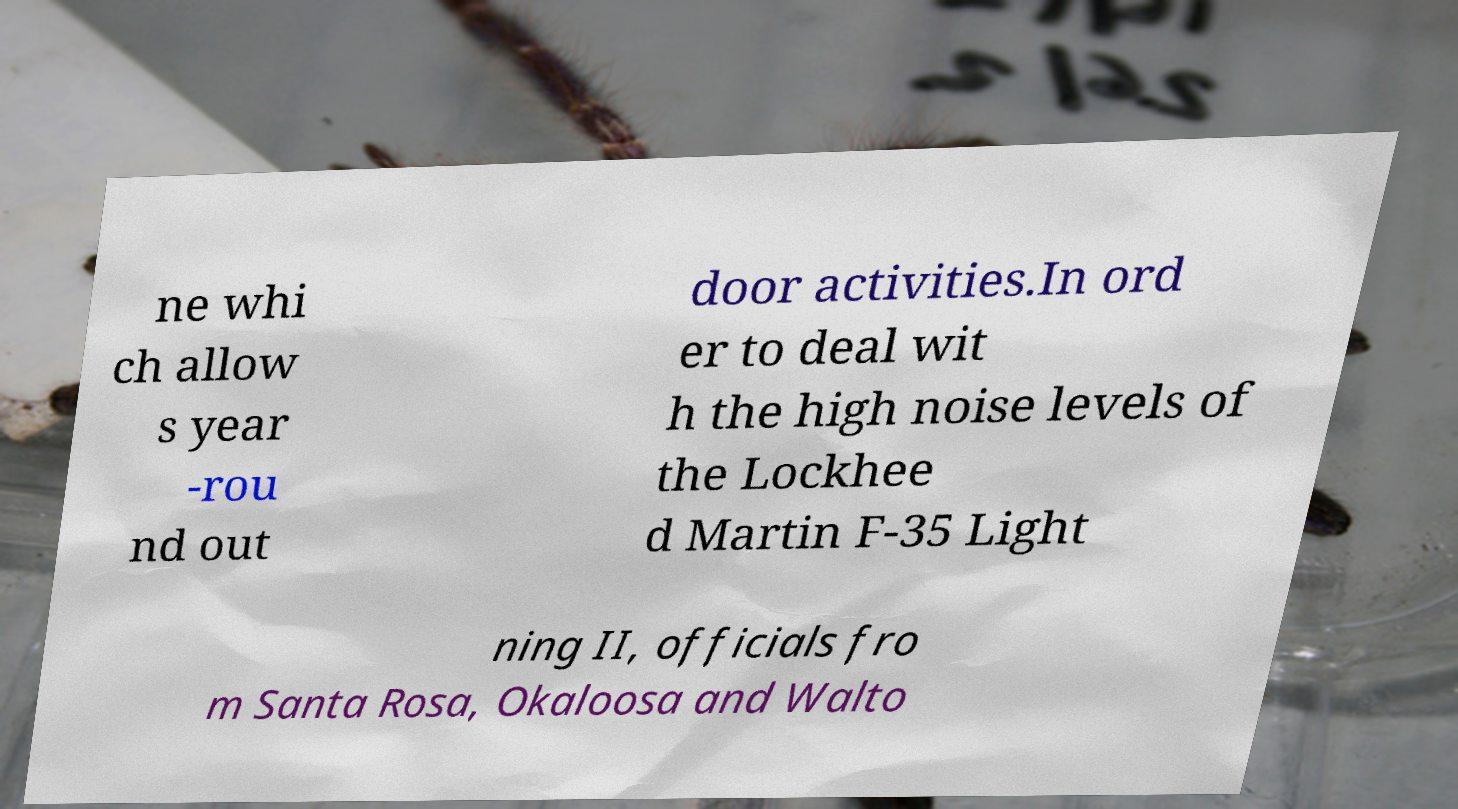What messages or text are displayed in this image? I need them in a readable, typed format. ne whi ch allow s year -rou nd out door activities.In ord er to deal wit h the high noise levels of the Lockhee d Martin F-35 Light ning II, officials fro m Santa Rosa, Okaloosa and Walto 